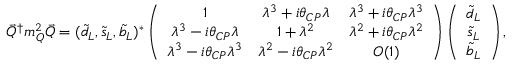<formula> <loc_0><loc_0><loc_500><loc_500>\vec { Q } ^ { \dag } m _ { Q } ^ { 2 } \vec { Q } = ( \tilde { d } _ { L } , \tilde { s } _ { L } , \tilde { b } _ { L } ) ^ { * } \left ( \begin{array} { c c c } { 1 } & { { \lambda ^ { 3 } + i \theta _ { C P } \lambda } } & { { \lambda ^ { 3 } + i \theta _ { C P } \lambda ^ { 3 } } } \\ { { \lambda ^ { 3 } - i \theta _ { C P } \lambda } } & { { 1 + \lambda ^ { 2 } } } & { { \lambda ^ { 2 } + i \theta _ { C P } \lambda ^ { 2 } } } \\ { { \lambda ^ { 3 } - i \theta _ { C P } \lambda ^ { 3 } } } & { { \lambda ^ { 2 } - i \theta _ { C P } \lambda ^ { 2 } } } & { O ( 1 ) } \end{array} \right ) \left ( \begin{array} { c } { { \tilde { d } _ { L } } } \\ { { \tilde { s } _ { L } } } \\ { { \tilde { b } _ { L } } } \end{array} \right ) ,</formula> 